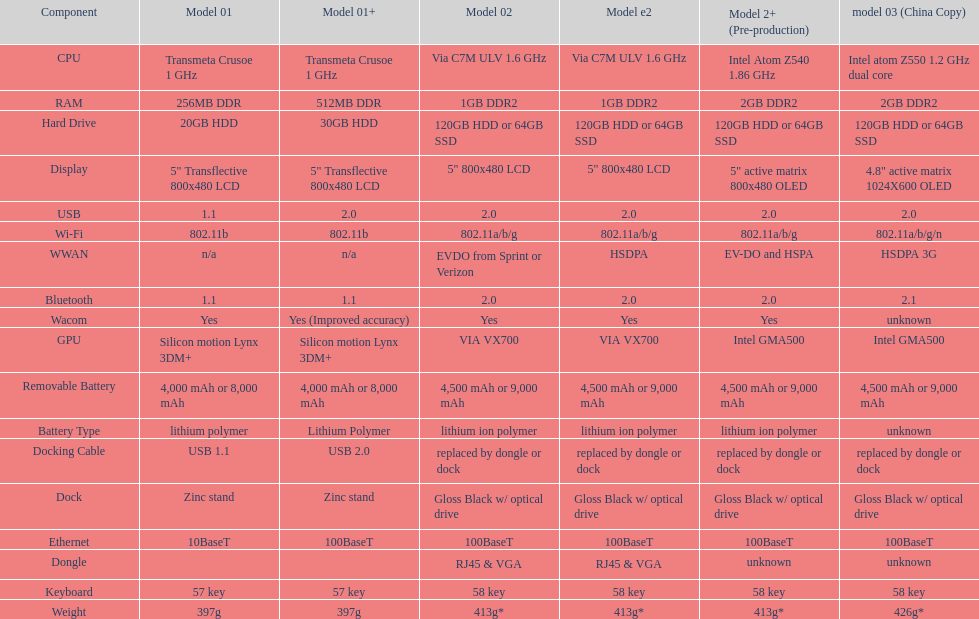The model 2 and model 2e are equipped with which cpu type? Via C7M ULV 1.6 GHz. 